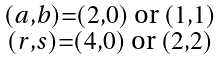<formula> <loc_0><loc_0><loc_500><loc_500>\begin{smallmatrix} ( a , b ) = ( 2 , 0 ) \text { or } ( 1 , 1 ) \\ ( r , s ) = ( 4 , 0 ) \text { or } ( 2 , 2 ) \end{smallmatrix}</formula> 